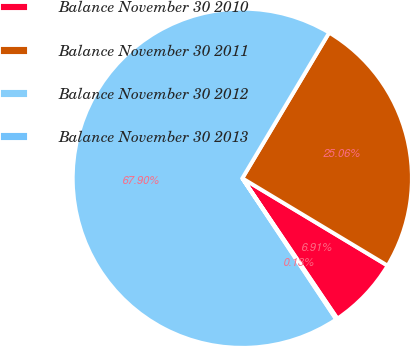Convert chart to OTSL. <chart><loc_0><loc_0><loc_500><loc_500><pie_chart><fcel>Balance November 30 2010<fcel>Balance November 30 2011<fcel>Balance November 30 2012<fcel>Balance November 30 2013<nl><fcel>6.91%<fcel>25.06%<fcel>67.91%<fcel>0.13%<nl></chart> 